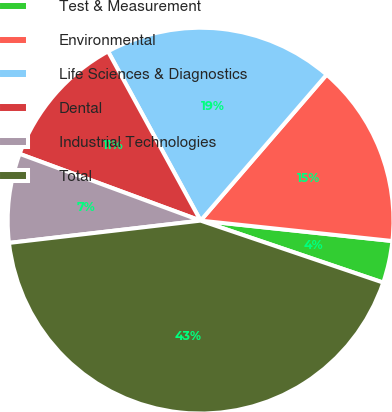Convert chart. <chart><loc_0><loc_0><loc_500><loc_500><pie_chart><fcel>Test & Measurement<fcel>Environmental<fcel>Life Sciences & Diagnostics<fcel>Dental<fcel>Industrial Technologies<fcel>Total<nl><fcel>3.52%<fcel>15.35%<fcel>19.3%<fcel>11.41%<fcel>7.47%<fcel>42.95%<nl></chart> 